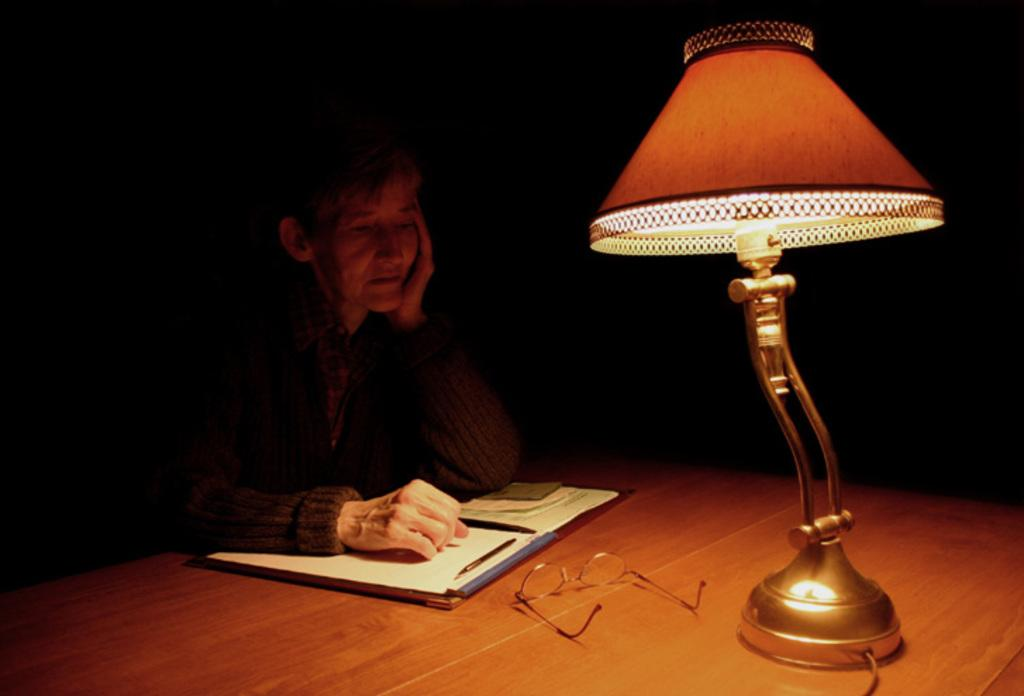What is the person in the image doing? There is a person sitting in the image. What is in front of the person? There is a table in front of the person. What can be seen on the table? The table has papers, spectacles, and other objects on it. Where is the lamp located in the image? The lamp is in the right corner of the image. How does the person plan to develop the smashed adjustment in the image? There is no mention of development, smashing, or adjustment in the image. The person is simply sitting at a table with papers, spectacles, and other objects. 